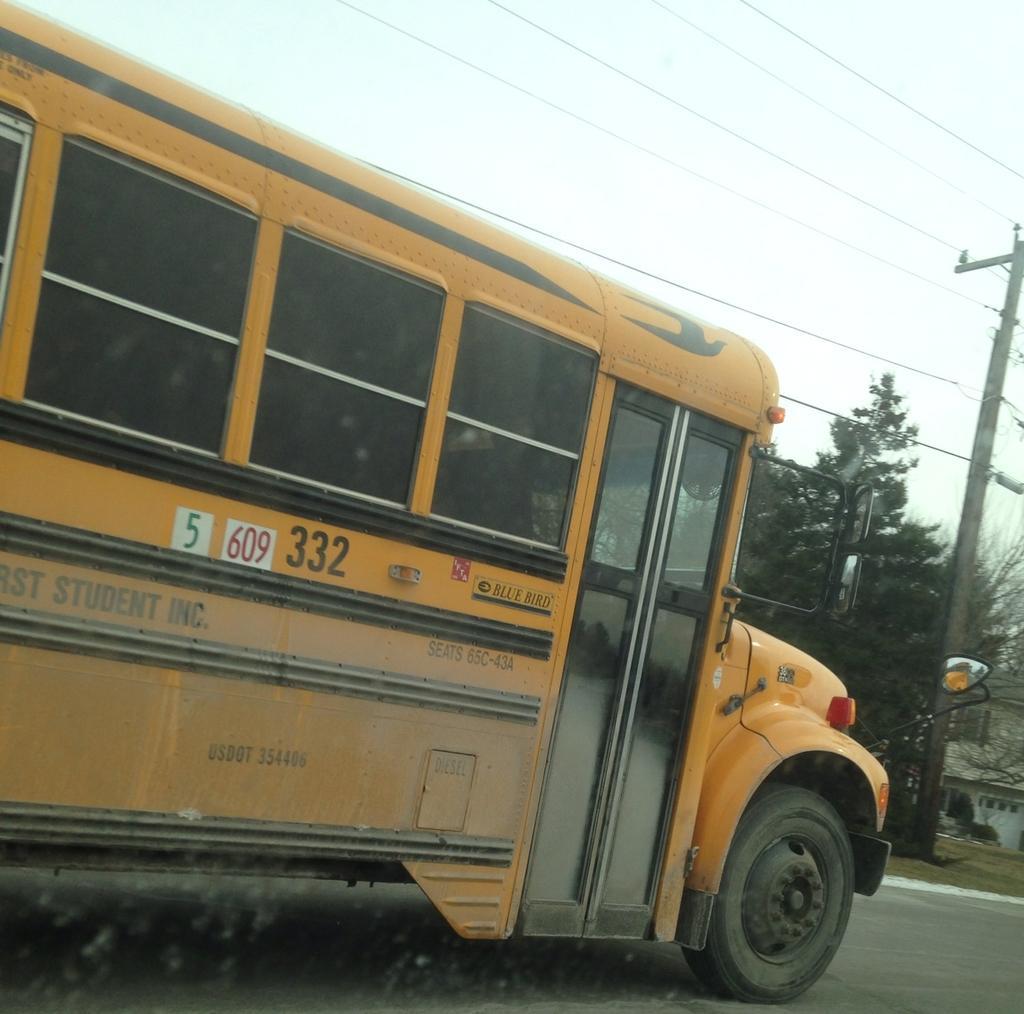Can you describe this image briefly? This picture contains a vehicle in yellow color is moving on the road. Beside that, there are trees and electric pole and wires. At the top of the picture, we see the sky. On the right side, we see a building. At the bottom of the picture, we see the road. 